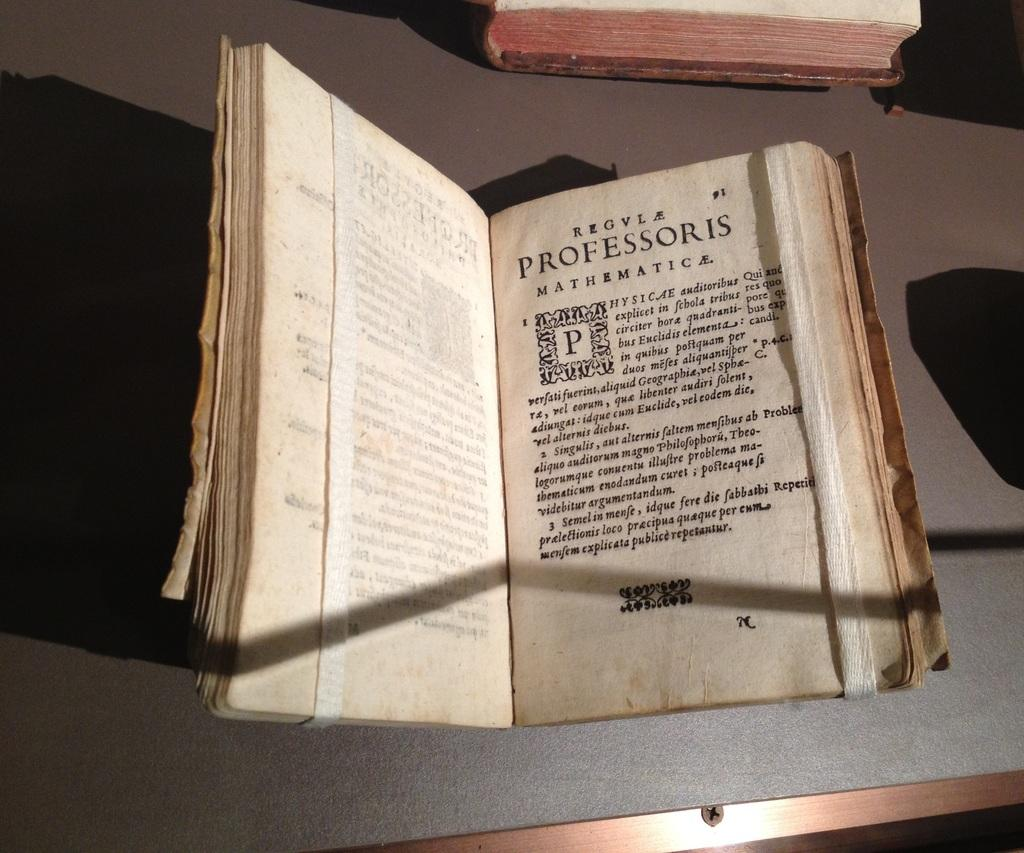Provide a one-sentence caption for the provided image. An old worn book made for a professor of mathematics. 